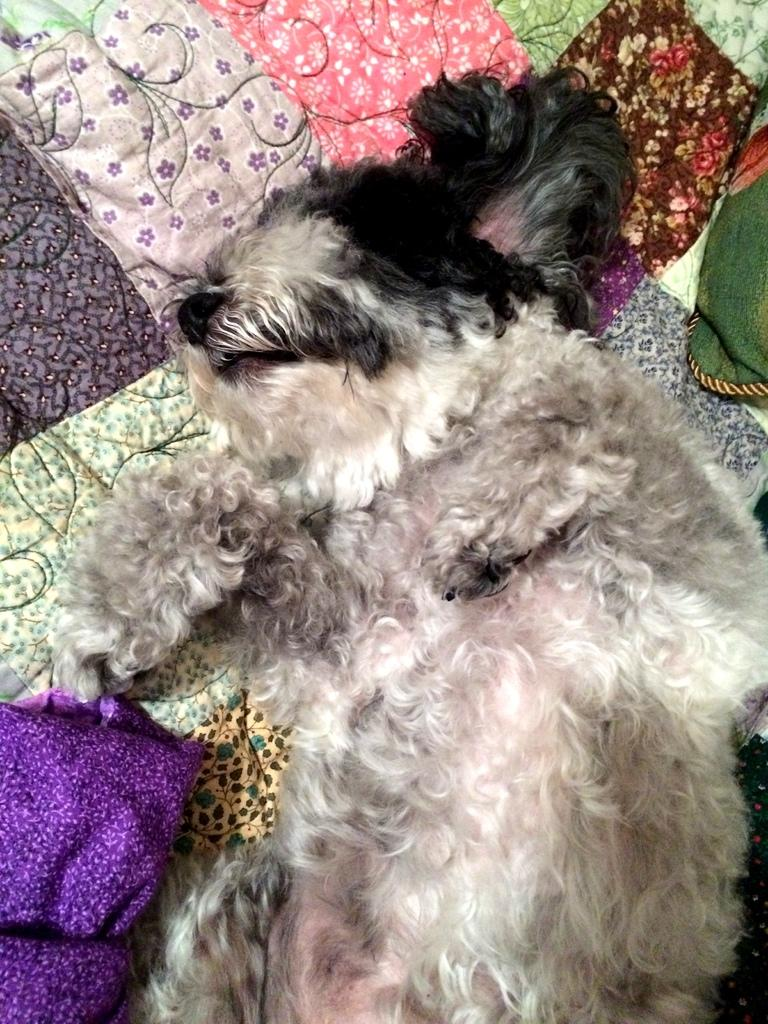What animal can be seen in the image? There is a dog in the image. What is the dog doing in the image? The dog is sleeping. Where is the dog located in the image? The dog is on a bed. How many rabbits are hopping around the dog in the image? There are no rabbits present in the image; it only features a dog sleeping on a bed. What type of tail does the airplane have in the image? There is no airplane present in the image, so it does not have a tail. 